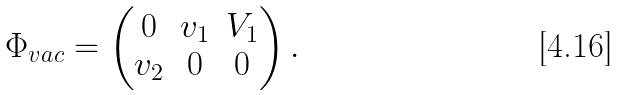Convert formula to latex. <formula><loc_0><loc_0><loc_500><loc_500>\Phi _ { v a c } = \begin{pmatrix} 0 & v _ { 1 } & V _ { 1 } \\ v _ { 2 } & 0 & 0 \end{pmatrix} .</formula> 